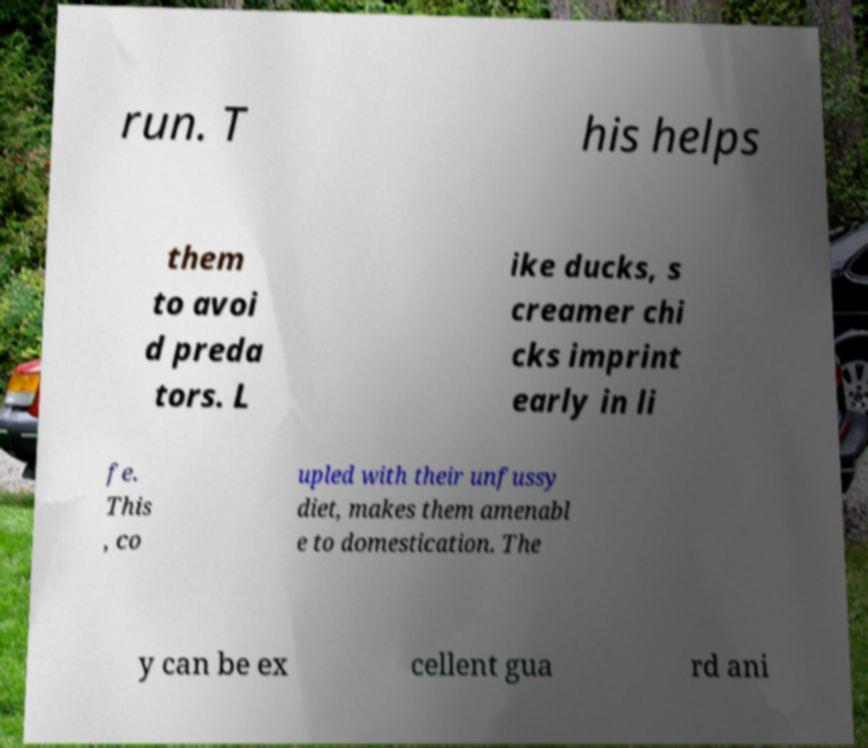There's text embedded in this image that I need extracted. Can you transcribe it verbatim? run. T his helps them to avoi d preda tors. L ike ducks, s creamer chi cks imprint early in li fe. This , co upled with their unfussy diet, makes them amenabl e to domestication. The y can be ex cellent gua rd ani 